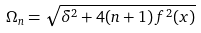<formula> <loc_0><loc_0><loc_500><loc_500>\Omega _ { n } = \sqrt { \delta ^ { 2 } + 4 ( n + 1 ) \, f ^ { 2 } ( x ) }</formula> 